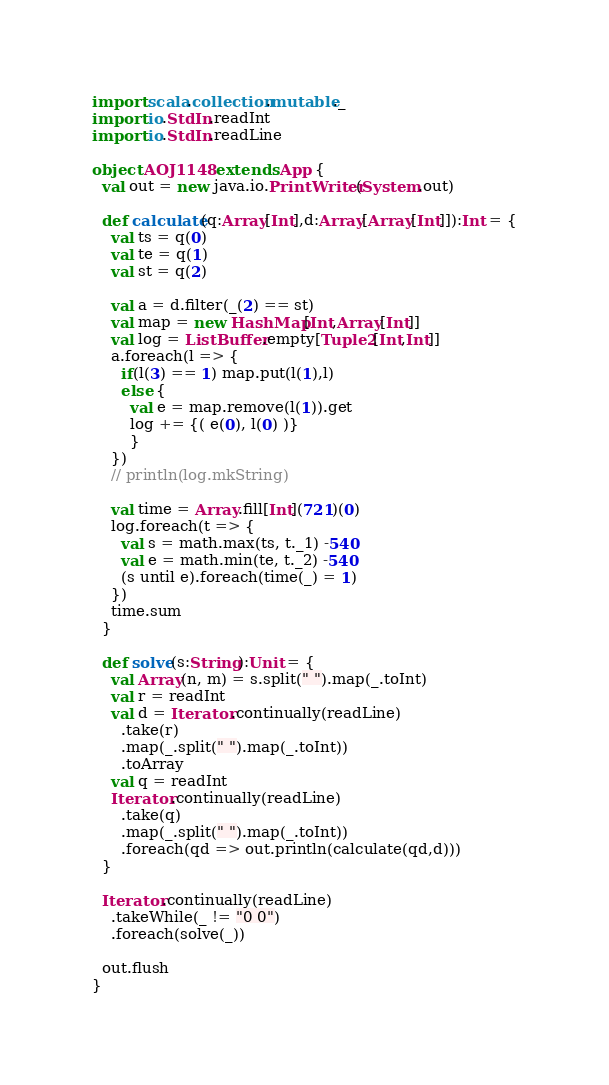<code> <loc_0><loc_0><loc_500><loc_500><_Scala_>import scala.collection.mutable._
import io.StdIn.readInt
import io.StdIn.readLine

object AOJ1148 extends App {
  val out = new java.io.PrintWriter(System.out)

  def calculate(q:Array[Int],d:Array[Array[Int]]):Int = {
    val ts = q(0)
    val te = q(1)
    val st = q(2)

    val a = d.filter(_(2) == st)
    val map = new HashMap[Int,Array[Int]]
    val log = ListBuffer.empty[Tuple2[Int,Int]]
    a.foreach(l => {
      if(l(3) == 1) map.put(l(1),l)
      else {
        val e = map.remove(l(1)).get
        log += {( e(0), l(0) )}
        }
    })
    // println(log.mkString)

    val time = Array.fill[Int](721)(0)
    log.foreach(t => {
      val s = math.max(ts, t._1) -540
      val e = math.min(te, t._2) -540
      (s until e).foreach(time(_) = 1)
    })
    time.sum
  }

  def solve(s:String):Unit = {
    val Array(n, m) = s.split(" ").map(_.toInt)
    val r = readInt
    val d = Iterator.continually(readLine)
      .take(r)
      .map(_.split(" ").map(_.toInt))
      .toArray
    val q = readInt
    Iterator.continually(readLine)
      .take(q)
      .map(_.split(" ").map(_.toInt))
      .foreach(qd => out.println(calculate(qd,d)))
  }

  Iterator.continually(readLine)
    .takeWhile(_ != "0 0")
    .foreach(solve(_))
  
  out.flush
}
</code> 